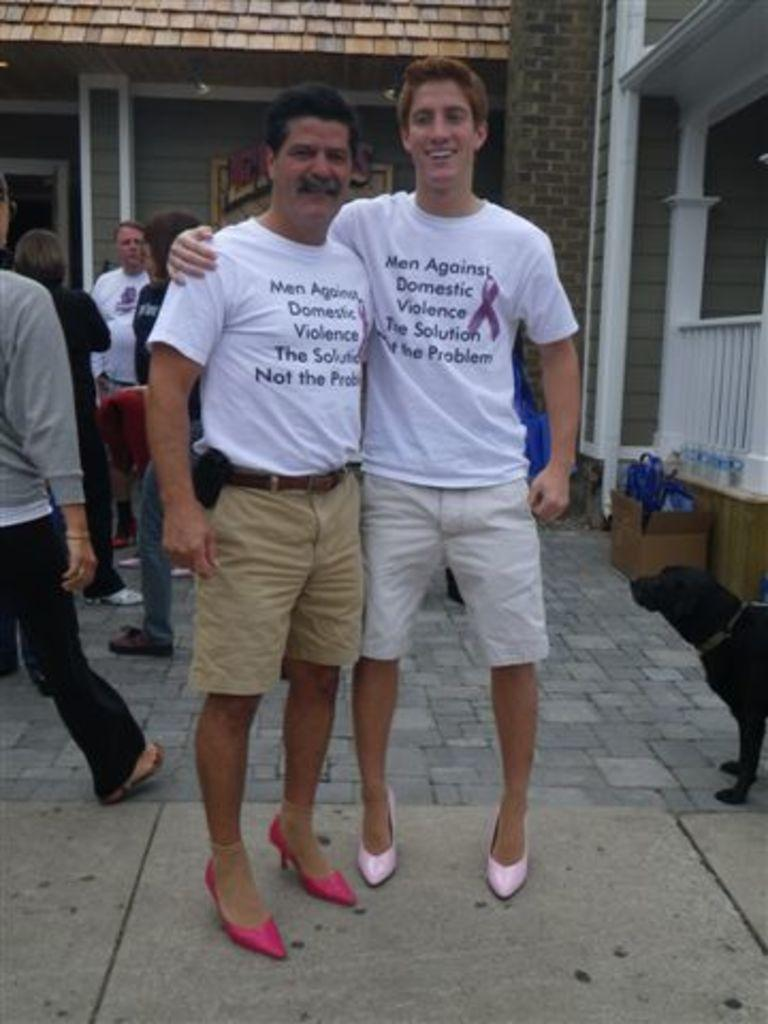How many people are visible in the image? There are two persons in the image. Can you describe the surroundings of the two persons? There are other persons and a dog in the background of the image, along with a building and other objects. What can be seen at the bottom of the image? The floor is visible at the bottom of the image. What statement does the tramp make in the image? There is no tramp present in the image, so no statement can be attributed to a tramp. 